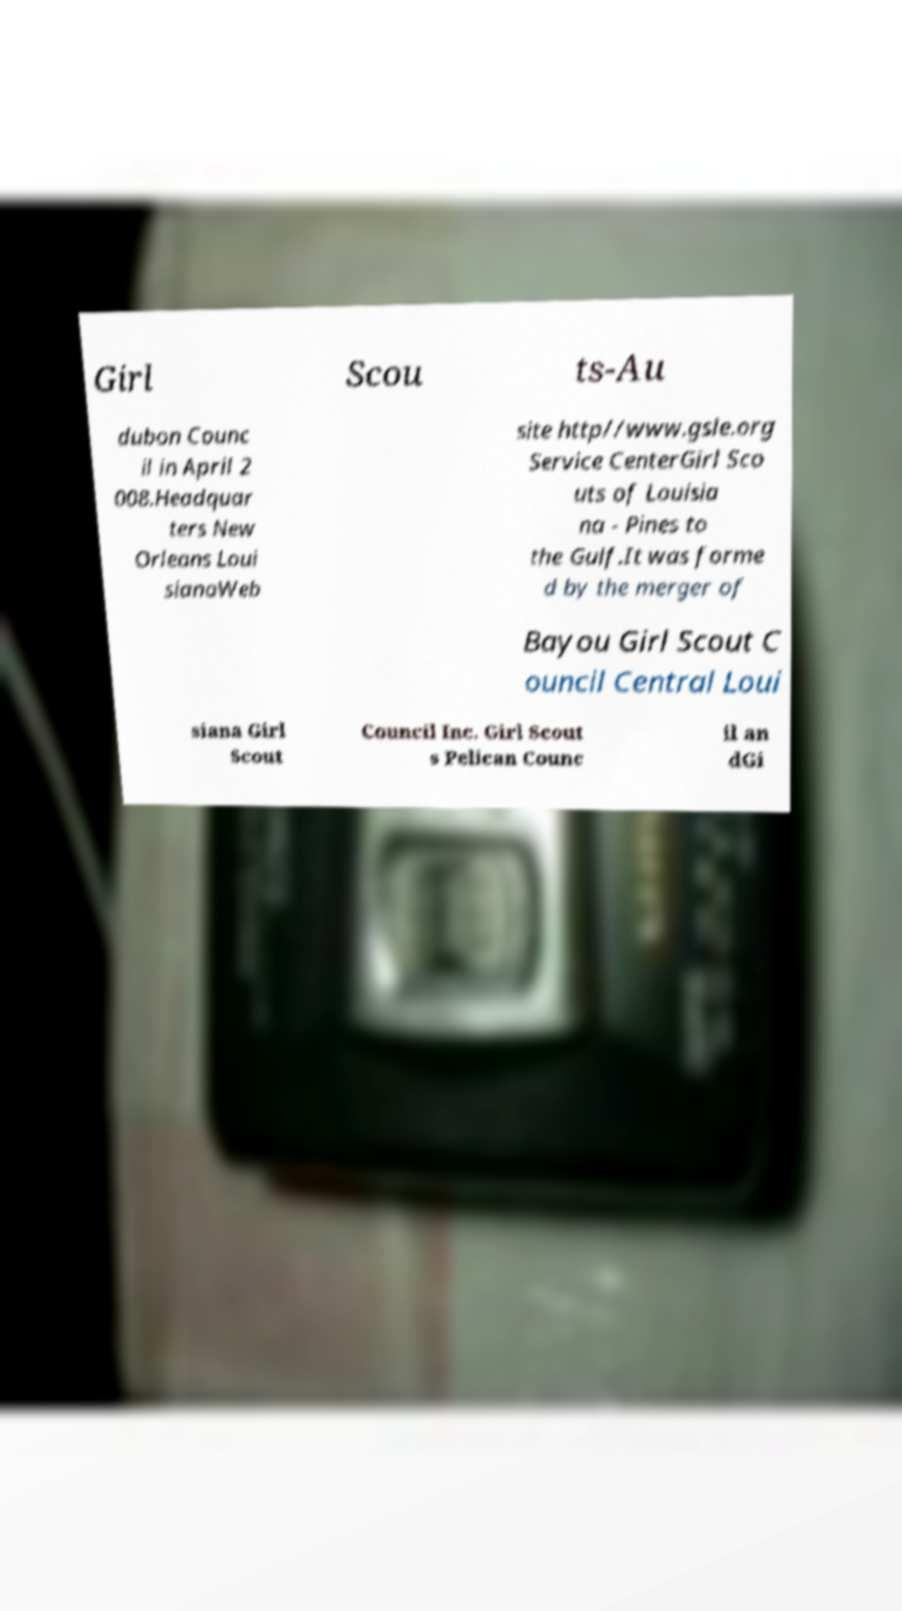What messages or text are displayed in this image? I need them in a readable, typed format. Girl Scou ts-Au dubon Counc il in April 2 008.Headquar ters New Orleans Loui sianaWeb site http//www.gsle.org Service CenterGirl Sco uts of Louisia na - Pines to the Gulf.It was forme d by the merger of Bayou Girl Scout C ouncil Central Loui siana Girl Scout Council Inc. Girl Scout s Pelican Counc il an dGi 